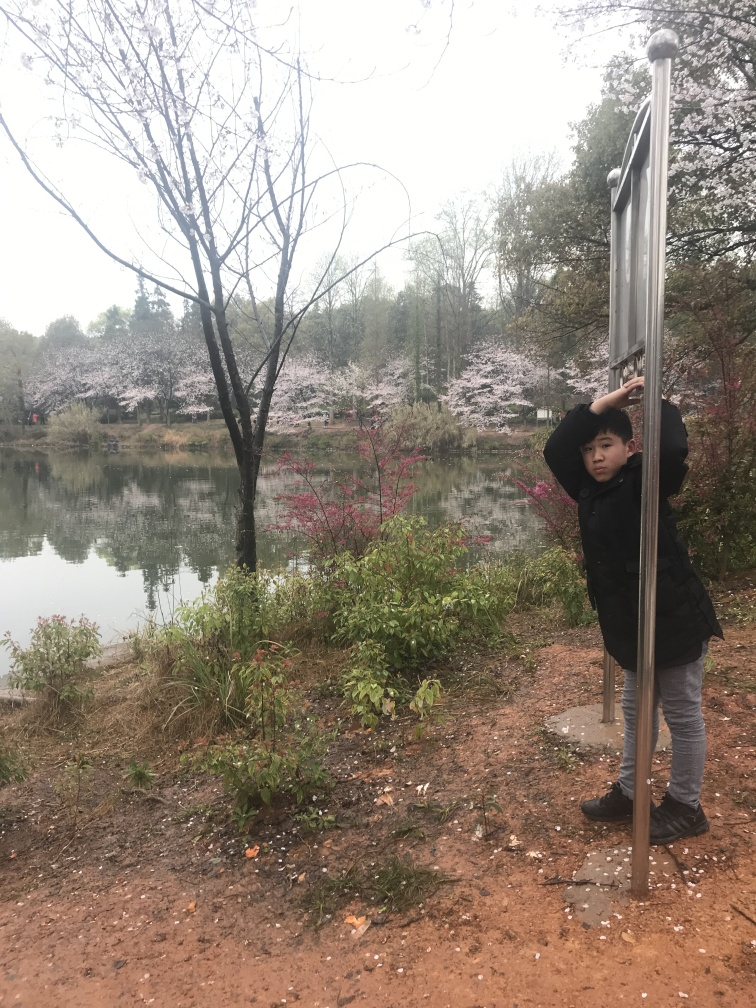How does the weather affect the mood of this image? The overcast sky and muted light in the image evoke a tranquil and somber mood, which is accentuated by the soft pink hues of the blossoming trees. This contrasts with the brighter and more vibrant atmosphere typically associated with a sunny day. The serene water and the lack of sunshine contribute to a reflective and peaceful setting. 